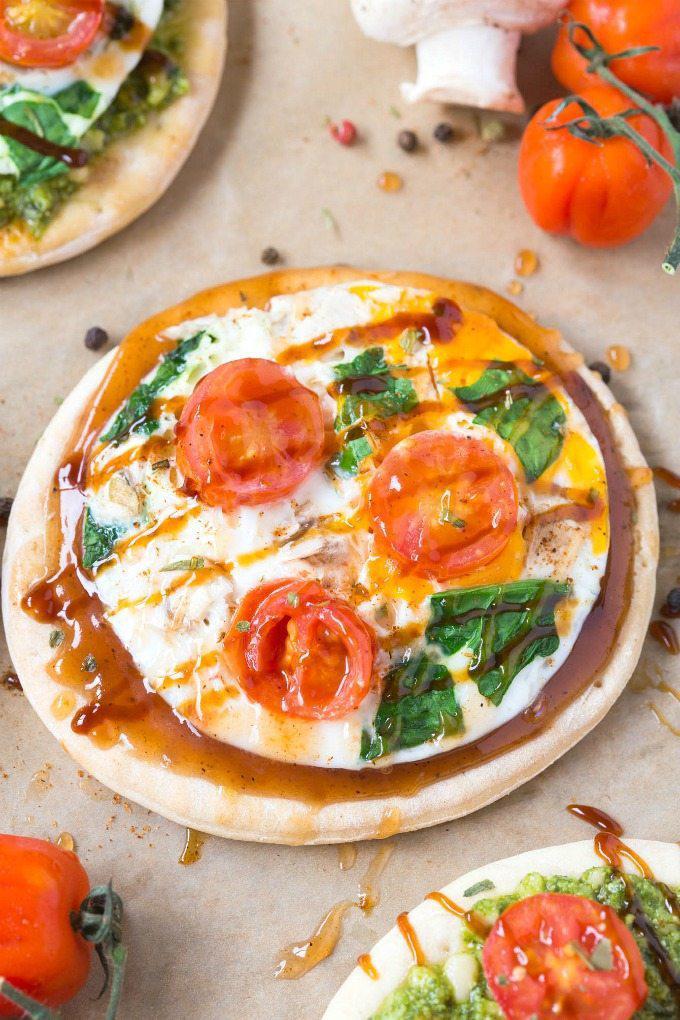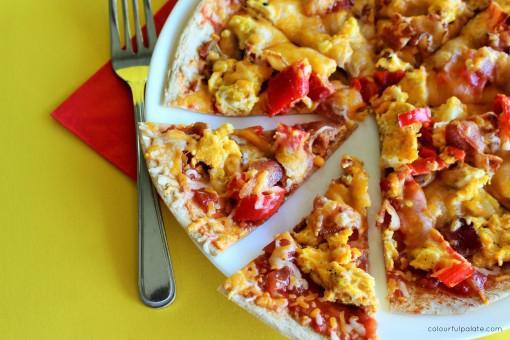The first image is the image on the left, the second image is the image on the right. Analyze the images presented: Is the assertion "Fewer than two slices of pizza can be seen on a white plate." valid? Answer yes or no. No. 